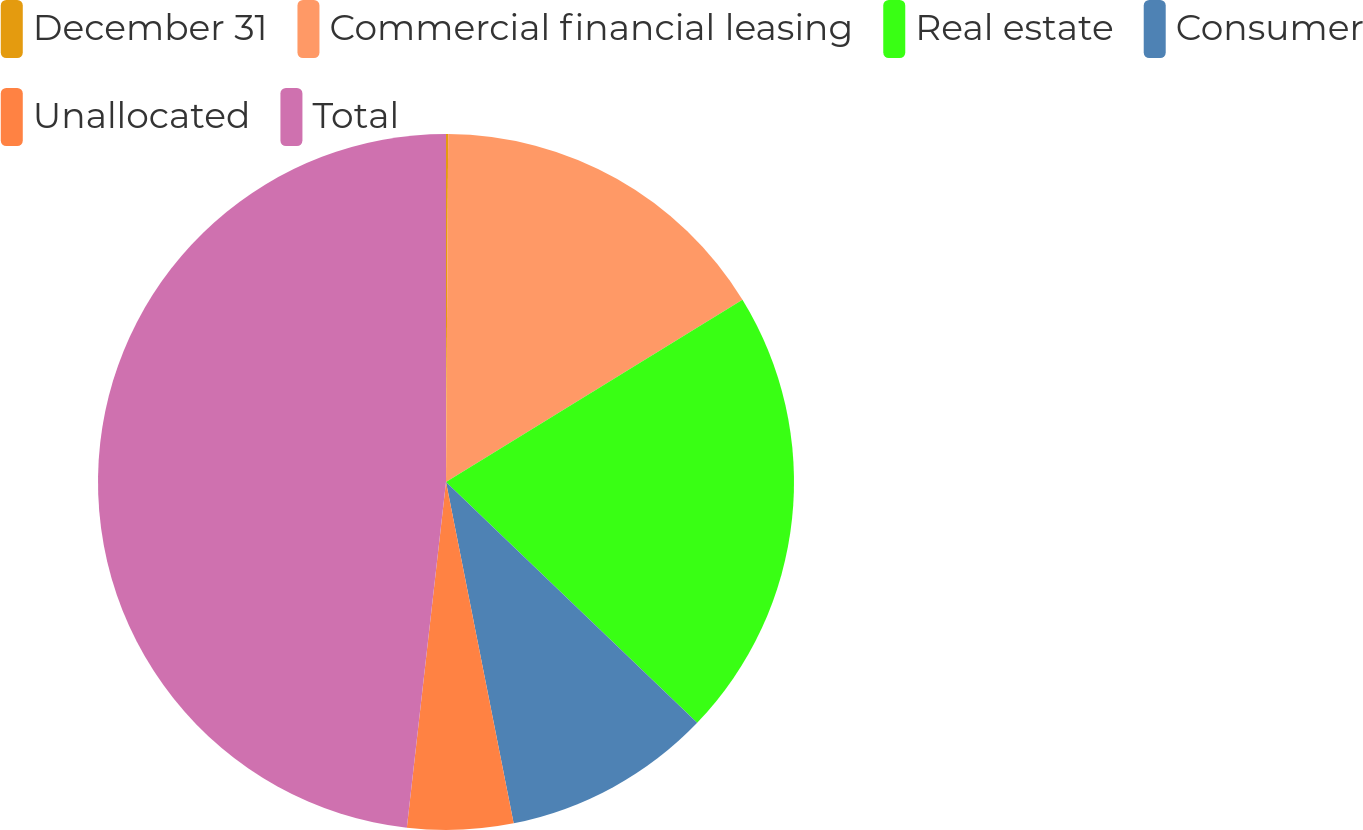Convert chart. <chart><loc_0><loc_0><loc_500><loc_500><pie_chart><fcel>December 31<fcel>Commercial financial leasing<fcel>Real estate<fcel>Consumer<fcel>Unallocated<fcel>Total<nl><fcel>0.1%<fcel>16.13%<fcel>20.94%<fcel>9.72%<fcel>4.91%<fcel>48.21%<nl></chart> 